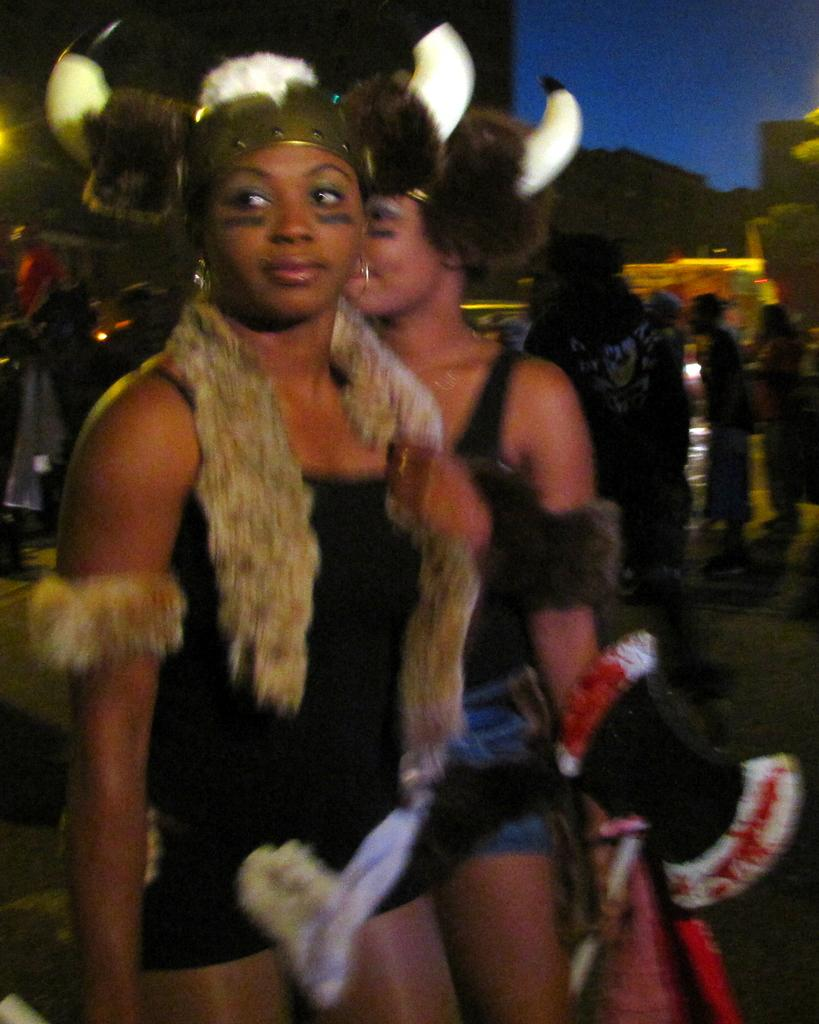How many people are in the group in the image? There is a group of people in the image, but the exact number is not specified. What can be observed about the attire of some people in the group? Some people in the group are wearing different costumes. What can be seen in the background of the image? There is a wall and the sky visible in the background of the image. Can you tell me what account number is written on the wall in the image? There is no account number visible on the wall in the image. What type of goat can be seen interacting with the people in the image? There is no goat present in the image; it features a group of people wearing different costumes. 